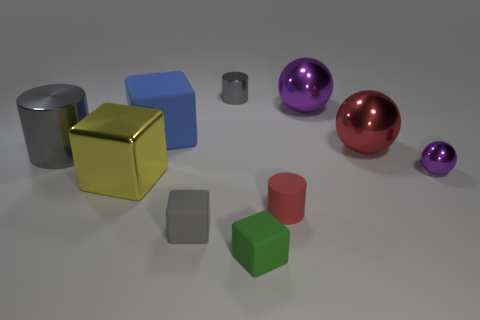The small cylinder that is to the left of the cube to the right of the tiny gray cylinder is made of what material?
Make the answer very short. Metal. Is there a gray cylinder?
Give a very brief answer. Yes. There is a tiny object that is behind the small red rubber cylinder and to the left of the tiny red rubber object; what material is it?
Ensure brevity in your answer.  Metal. Are there more large blocks that are on the left side of the big gray cylinder than blue things that are right of the small green rubber block?
Provide a succinct answer. No. Are there any red matte cubes that have the same size as the gray matte object?
Your answer should be very brief. No. What size is the gray metallic cylinder on the left side of the gray cylinder behind the gray metallic cylinder that is in front of the big blue thing?
Your answer should be very brief. Large. The tiny metal ball is what color?
Keep it short and to the point. Purple. Is the number of blue rubber blocks that are behind the big blue object greater than the number of red things?
Offer a very short reply. No. There is a tiny matte cylinder; what number of small gray cylinders are to the right of it?
Keep it short and to the point. 0. There is a big metallic object that is the same color as the small rubber cylinder; what shape is it?
Provide a succinct answer. Sphere. 